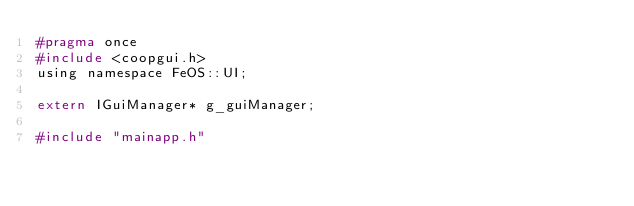<code> <loc_0><loc_0><loc_500><loc_500><_C_>#pragma once
#include <coopgui.h>
using namespace FeOS::UI;

extern IGuiManager* g_guiManager;

#include "mainapp.h"
</code> 